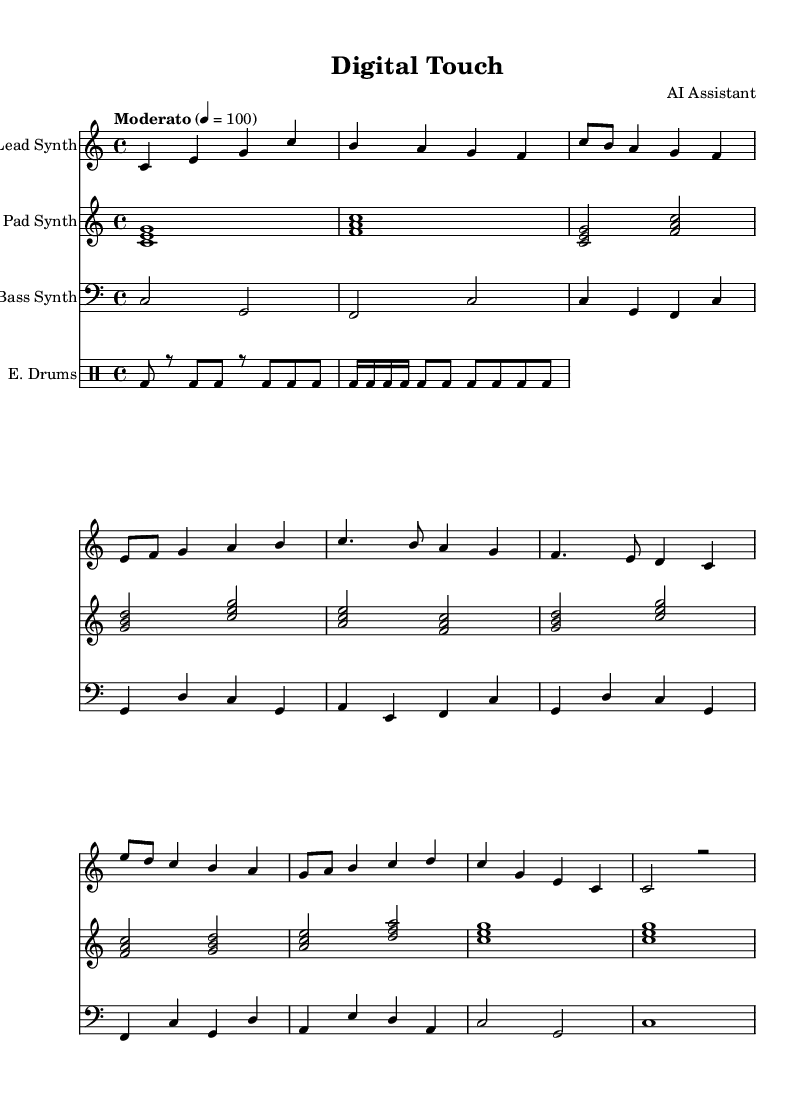What is the key signature of this music? The key signature is indicated at the beginning of the piece. This music is composed in C major, which is characterized by having no sharps or flats in its key signature.
Answer: C major What is the time signature of the music? The time signature is shown in the first measure of the score. It indicates that there are four beats in a measure and the quarter note gets one beat, which is represented as 4/4.
Answer: 4/4 What is the tempo marking for the piece? The tempo indication is provided above the staff, stating "Moderato" with a metronome marking of 4 = 100. This means that the music should be played at a moderate speed, with a specific tempo of 100 beats per minute.
Answer: Moderato 4 = 100 How many different synthesizer parts are present? By examining the sheet music, we can count three parts specifically labeled: Lead Synth, Pad Synth, and Bass Synth. This indicates that there are three distinct synthesizer sections in the composition.
Answer: Three What is the rhythm pattern of the electronic drums in the introduction? The electronic drum section shows a repeated rhythmic pattern in the first measure, which consists of a bass drum hit on the first and third beats followed by rests. Notably, it repeats this pattern establishing a groove in the introduction.
Answer: Bass drum pattern Which section contains the highest notes played by the lead synth? In the chorus section, the lead synth plays the highest notes, particularly the note 'c' which is an octave higher compared to the other sections. This is found in the part labeled as "Chorus" in the lead synth track.
Answer: Chorus 